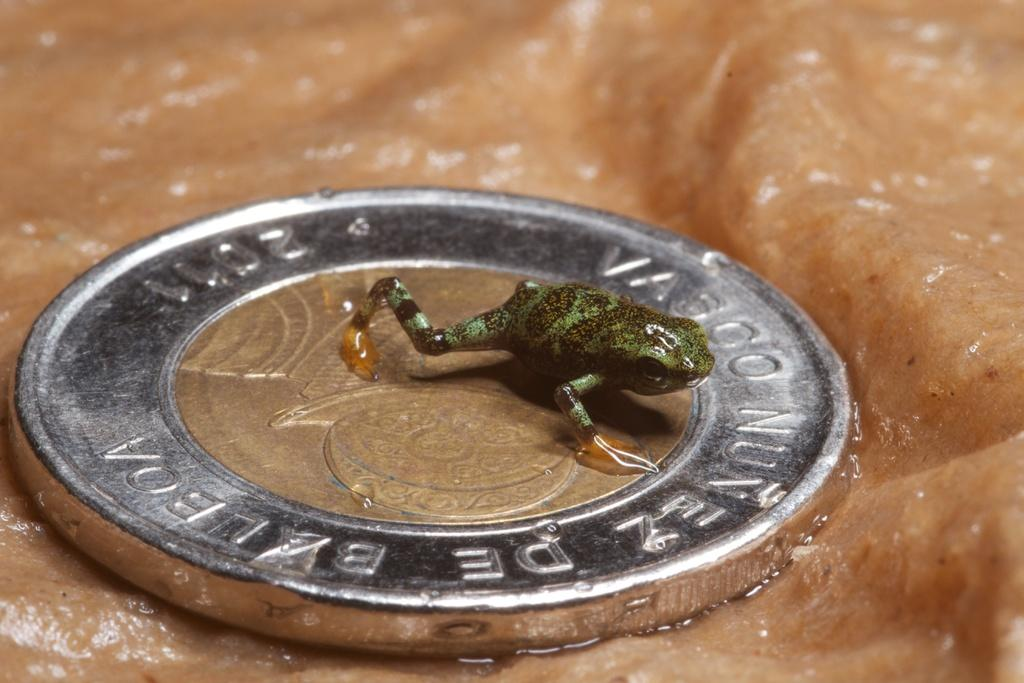What object is the main focus of the image? There is a coin in the image. Where is the coin located? The coin is on a surface. What is depicted on the surface where the coin is located? The surface has a depiction of a frog. What type of powder is being used by the beggar in the image? There is no beggar or powder present in the image; it only features a coin on a surface with a frog depiction. 